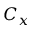<formula> <loc_0><loc_0><loc_500><loc_500>C _ { x }</formula> 